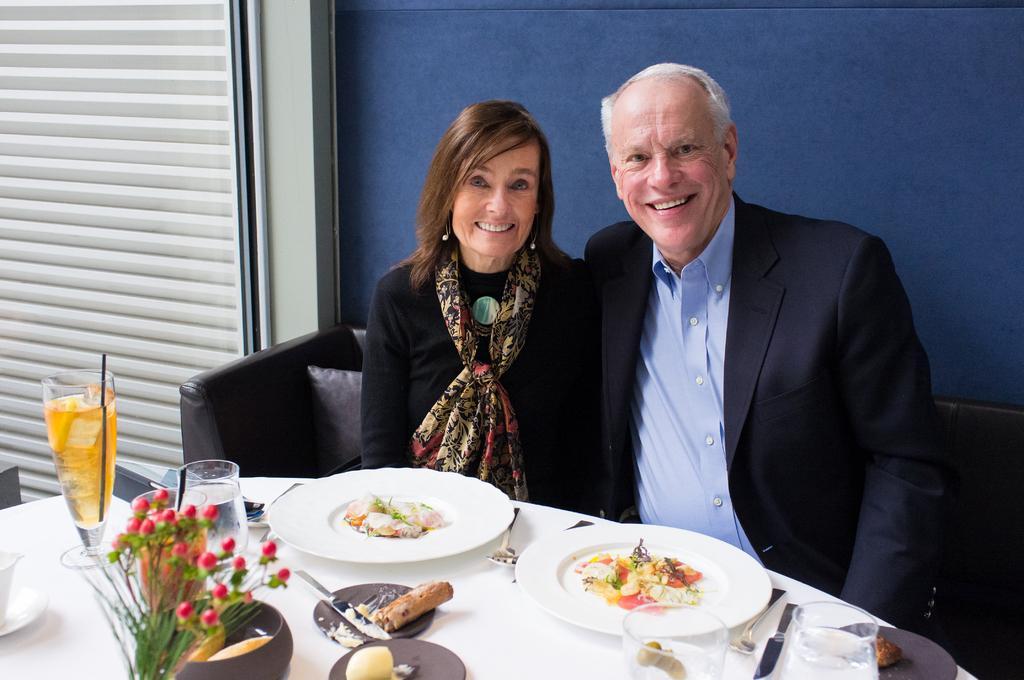Please provide a concise description of this image. In this picture there is a man and woman sitting and woman is sitting beside him, both are smiling, there is a table in front of them which has wine glass, water glasses, a plant small plates, knife, spoons and plates of with food and in the backdrop there is a wall. 